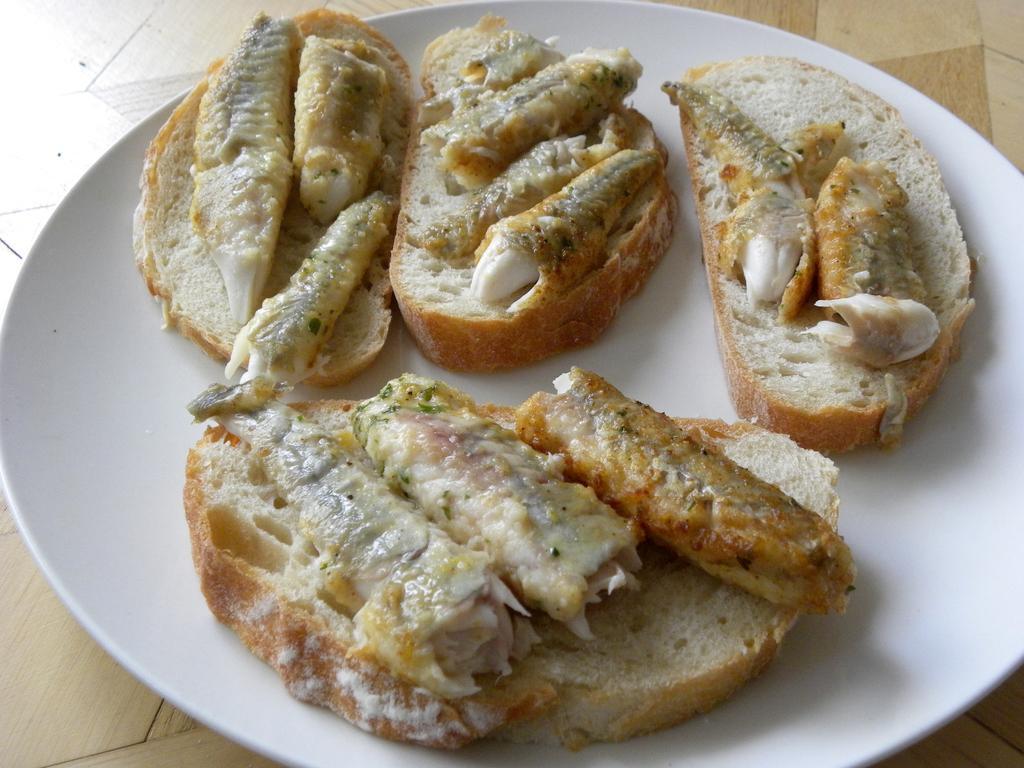Could you give a brief overview of what you see in this image? In this image there is a plate. On the plate there are bread pieces. 